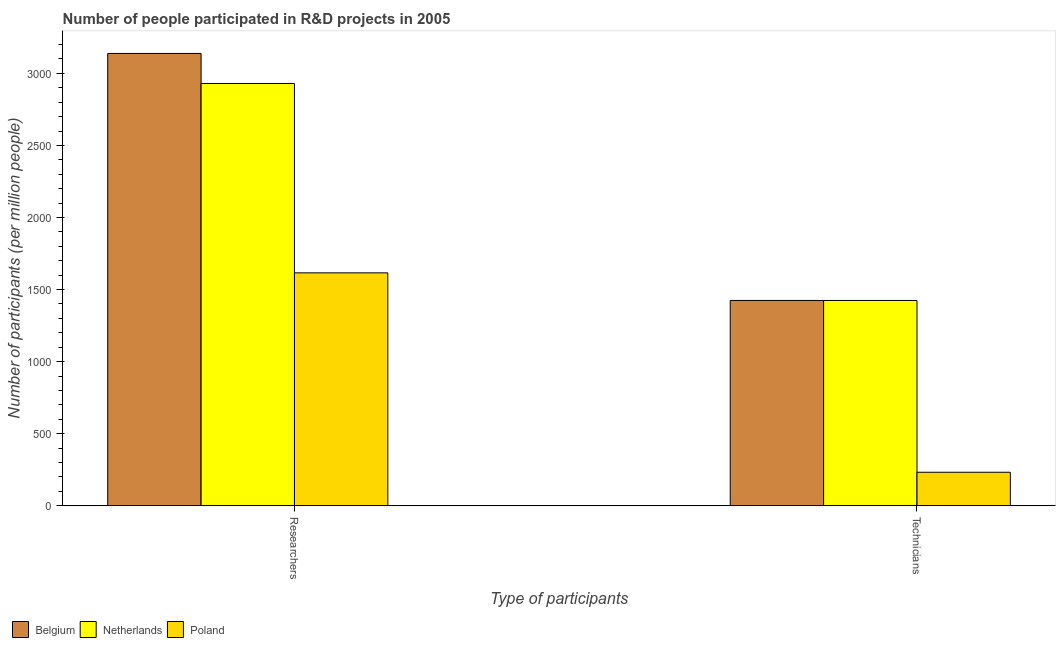How many different coloured bars are there?
Ensure brevity in your answer.  3. How many groups of bars are there?
Make the answer very short. 2. What is the label of the 2nd group of bars from the left?
Ensure brevity in your answer.  Technicians. What is the number of researchers in Belgium?
Your response must be concise. 3138.4. Across all countries, what is the maximum number of technicians?
Give a very brief answer. 1424.67. Across all countries, what is the minimum number of researchers?
Offer a very short reply. 1616.13. In which country was the number of technicians maximum?
Provide a short and direct response. Belgium. In which country was the number of technicians minimum?
Keep it short and to the point. Poland. What is the total number of technicians in the graph?
Your answer should be compact. 3081.82. What is the difference between the number of technicians in Netherlands and that in Belgium?
Offer a terse response. -0.14. What is the difference between the number of researchers in Belgium and the number of technicians in Poland?
Provide a short and direct response. 2905.79. What is the average number of technicians per country?
Your response must be concise. 1027.27. What is the difference between the number of technicians and number of researchers in Netherlands?
Provide a succinct answer. -1505.6. What is the ratio of the number of technicians in Poland to that in Belgium?
Provide a succinct answer. 0.16. What does the 1st bar from the left in Researchers represents?
Provide a succinct answer. Belgium. What does the 1st bar from the right in Technicians represents?
Keep it short and to the point. Poland. Are all the bars in the graph horizontal?
Offer a very short reply. No. How many countries are there in the graph?
Your answer should be very brief. 3. What is the difference between two consecutive major ticks on the Y-axis?
Provide a short and direct response. 500. Are the values on the major ticks of Y-axis written in scientific E-notation?
Your response must be concise. No. Does the graph contain grids?
Provide a succinct answer. No. How many legend labels are there?
Offer a very short reply. 3. What is the title of the graph?
Provide a short and direct response. Number of people participated in R&D projects in 2005. What is the label or title of the X-axis?
Provide a short and direct response. Type of participants. What is the label or title of the Y-axis?
Ensure brevity in your answer.  Number of participants (per million people). What is the Number of participants (per million people) in Belgium in Researchers?
Keep it short and to the point. 3138.4. What is the Number of participants (per million people) in Netherlands in Researchers?
Your answer should be very brief. 2930.14. What is the Number of participants (per million people) in Poland in Researchers?
Provide a succinct answer. 1616.13. What is the Number of participants (per million people) in Belgium in Technicians?
Ensure brevity in your answer.  1424.67. What is the Number of participants (per million people) in Netherlands in Technicians?
Your answer should be very brief. 1424.53. What is the Number of participants (per million people) of Poland in Technicians?
Ensure brevity in your answer.  232.61. Across all Type of participants, what is the maximum Number of participants (per million people) in Belgium?
Keep it short and to the point. 3138.4. Across all Type of participants, what is the maximum Number of participants (per million people) of Netherlands?
Offer a terse response. 2930.14. Across all Type of participants, what is the maximum Number of participants (per million people) in Poland?
Make the answer very short. 1616.13. Across all Type of participants, what is the minimum Number of participants (per million people) in Belgium?
Ensure brevity in your answer.  1424.67. Across all Type of participants, what is the minimum Number of participants (per million people) in Netherlands?
Keep it short and to the point. 1424.53. Across all Type of participants, what is the minimum Number of participants (per million people) in Poland?
Make the answer very short. 232.61. What is the total Number of participants (per million people) in Belgium in the graph?
Your answer should be very brief. 4563.07. What is the total Number of participants (per million people) of Netherlands in the graph?
Make the answer very short. 4354.67. What is the total Number of participants (per million people) of Poland in the graph?
Provide a succinct answer. 1848.74. What is the difference between the Number of participants (per million people) in Belgium in Researchers and that in Technicians?
Keep it short and to the point. 1713.73. What is the difference between the Number of participants (per million people) of Netherlands in Researchers and that in Technicians?
Your answer should be compact. 1505.6. What is the difference between the Number of participants (per million people) of Poland in Researchers and that in Technicians?
Provide a succinct answer. 1383.52. What is the difference between the Number of participants (per million people) in Belgium in Researchers and the Number of participants (per million people) in Netherlands in Technicians?
Keep it short and to the point. 1713.87. What is the difference between the Number of participants (per million people) in Belgium in Researchers and the Number of participants (per million people) in Poland in Technicians?
Provide a short and direct response. 2905.79. What is the difference between the Number of participants (per million people) in Netherlands in Researchers and the Number of participants (per million people) in Poland in Technicians?
Your answer should be very brief. 2697.53. What is the average Number of participants (per million people) of Belgium per Type of participants?
Provide a succinct answer. 2281.54. What is the average Number of participants (per million people) in Netherlands per Type of participants?
Your answer should be very brief. 2177.34. What is the average Number of participants (per million people) in Poland per Type of participants?
Offer a very short reply. 924.37. What is the difference between the Number of participants (per million people) of Belgium and Number of participants (per million people) of Netherlands in Researchers?
Ensure brevity in your answer.  208.26. What is the difference between the Number of participants (per million people) of Belgium and Number of participants (per million people) of Poland in Researchers?
Make the answer very short. 1522.27. What is the difference between the Number of participants (per million people) in Netherlands and Number of participants (per million people) in Poland in Researchers?
Ensure brevity in your answer.  1314.01. What is the difference between the Number of participants (per million people) in Belgium and Number of participants (per million people) in Netherlands in Technicians?
Your answer should be compact. 0.14. What is the difference between the Number of participants (per million people) of Belgium and Number of participants (per million people) of Poland in Technicians?
Ensure brevity in your answer.  1192.06. What is the difference between the Number of participants (per million people) of Netherlands and Number of participants (per million people) of Poland in Technicians?
Provide a short and direct response. 1191.92. What is the ratio of the Number of participants (per million people) of Belgium in Researchers to that in Technicians?
Ensure brevity in your answer.  2.2. What is the ratio of the Number of participants (per million people) of Netherlands in Researchers to that in Technicians?
Offer a terse response. 2.06. What is the ratio of the Number of participants (per million people) of Poland in Researchers to that in Technicians?
Offer a very short reply. 6.95. What is the difference between the highest and the second highest Number of participants (per million people) of Belgium?
Ensure brevity in your answer.  1713.73. What is the difference between the highest and the second highest Number of participants (per million people) in Netherlands?
Offer a very short reply. 1505.6. What is the difference between the highest and the second highest Number of participants (per million people) of Poland?
Offer a terse response. 1383.52. What is the difference between the highest and the lowest Number of participants (per million people) of Belgium?
Make the answer very short. 1713.73. What is the difference between the highest and the lowest Number of participants (per million people) in Netherlands?
Ensure brevity in your answer.  1505.6. What is the difference between the highest and the lowest Number of participants (per million people) of Poland?
Your answer should be very brief. 1383.52. 